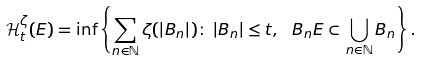<formula> <loc_0><loc_0><loc_500><loc_500>\mathcal { H } ^ { \zeta } _ { t } ( E ) = \inf \left \{ \sum _ { n \in \mathbb { N } } \zeta ( | B _ { n } | ) \colon \, | B _ { n } | \leq t , \ B _ { n } E \subset \bigcup _ { n \in \mathbb { N } } B _ { n } \right \} .</formula> 